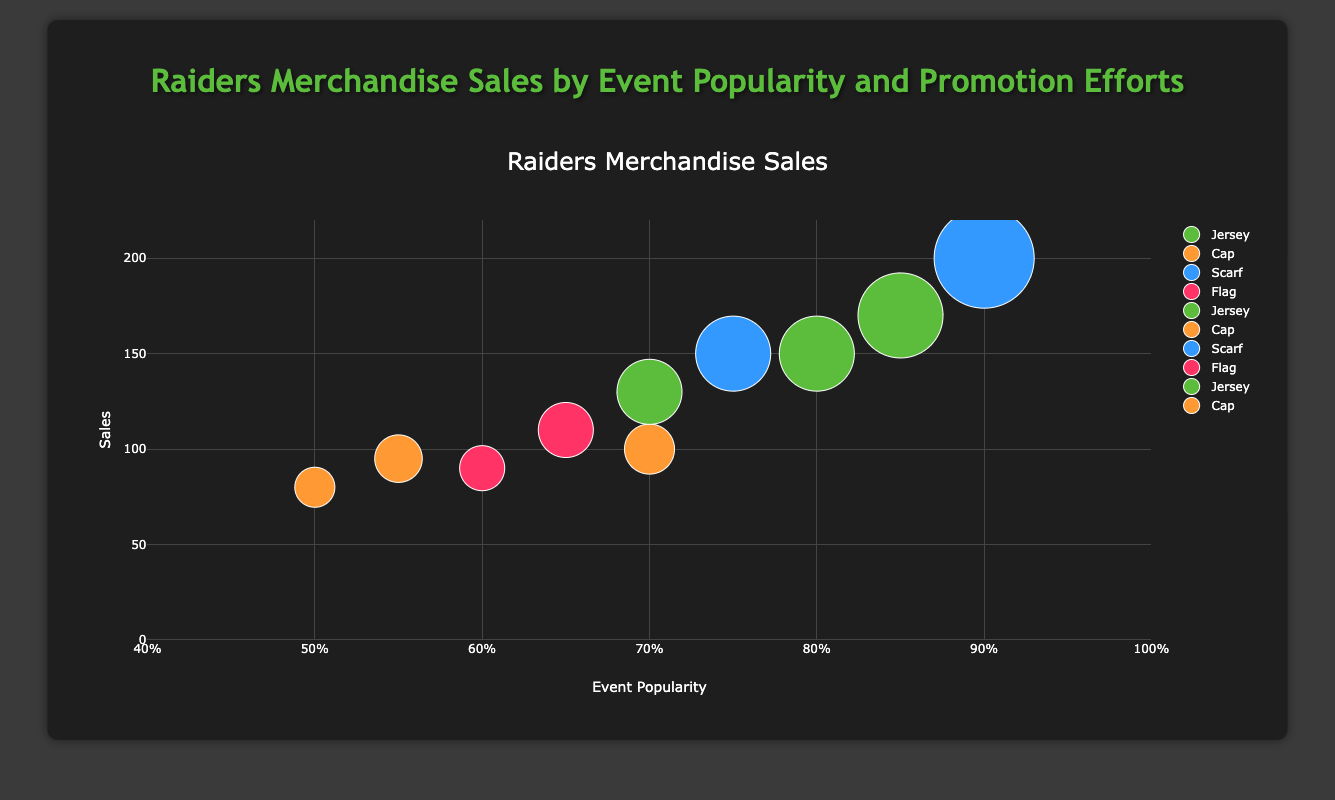What is the title of the chart? The title of the chart is displayed prominently at the top center of the figure, and the textual information indicates the overall topic of the chart.
Answer: Raiders Merchandise Sales by Event Popularity and Promotion Efforts What is the range of the x-axis (Event Popularity)? The range of the x-axis is indicated by the minimum and maximum values shown on it.
Answer: 0.4 to 1 Which item type had the highest sales and at which event? By observing the bubbles representing each item type and their sales, the bubble with the largest diameter indicates the highest sales. We can find the associated event by checking the text information of the bubble.
Answer: Scarf at Home Game vs Brisbane Broncos What is the average event popularity for all Jersey sales? First, identify all the bubbles representing "Jersey." Then, extract their event popularity values and calculate their average. (0.8 + 0.85 + 0.7) / 3
Answer: 0.78 How many different types of promotional efforts are represented, and which ones? By looking at the information provided about each bubble, we can count the unique promotional efforts mentioned.
Answer: 4: Email Campaign, Social Media Blast, In-Stadium Promotions, Website Banner Ads Which event had the lowest sales, and what was the item type? Locate the smallest bubble (least diameter) to identify the lowest sales and refer to its text information.
Answer: Home Game vs Manly Sea Eagles, Cap Compare the sales of Caps vs Jerseys. Which had higher sales on average? Calculate the average sales for both Caps and Jerseys separately, then compare these averages. Caps: (100 + 80 + 95) / 3 = 91.67; Jerseys: (150 + 170 + 130) / 3 = 150
Answer: Jerseys had higher sales on average What is the relationship between event popularity and sales for Scarves? Identify the bubbles for "Scarf" and observe their placement on the x-axis vs. y-axis to understand the trend. Higher event popularity seems correlated with higher sales for Scarves.
Answer: Positive correlation Which promotional effort corresponds with the highest event popularity for Flags? By looking at all Flag bubbles and their event popularity values, identify the highest event popularity and check the corresponding promotion effort.
Answer: Email Campaign What is the total sales for items promoted through Social Media Blast? Sum the sales values for all items that used the "Social Media Blast" promotional method. (100 + 80 + 95)
Answer: 275 